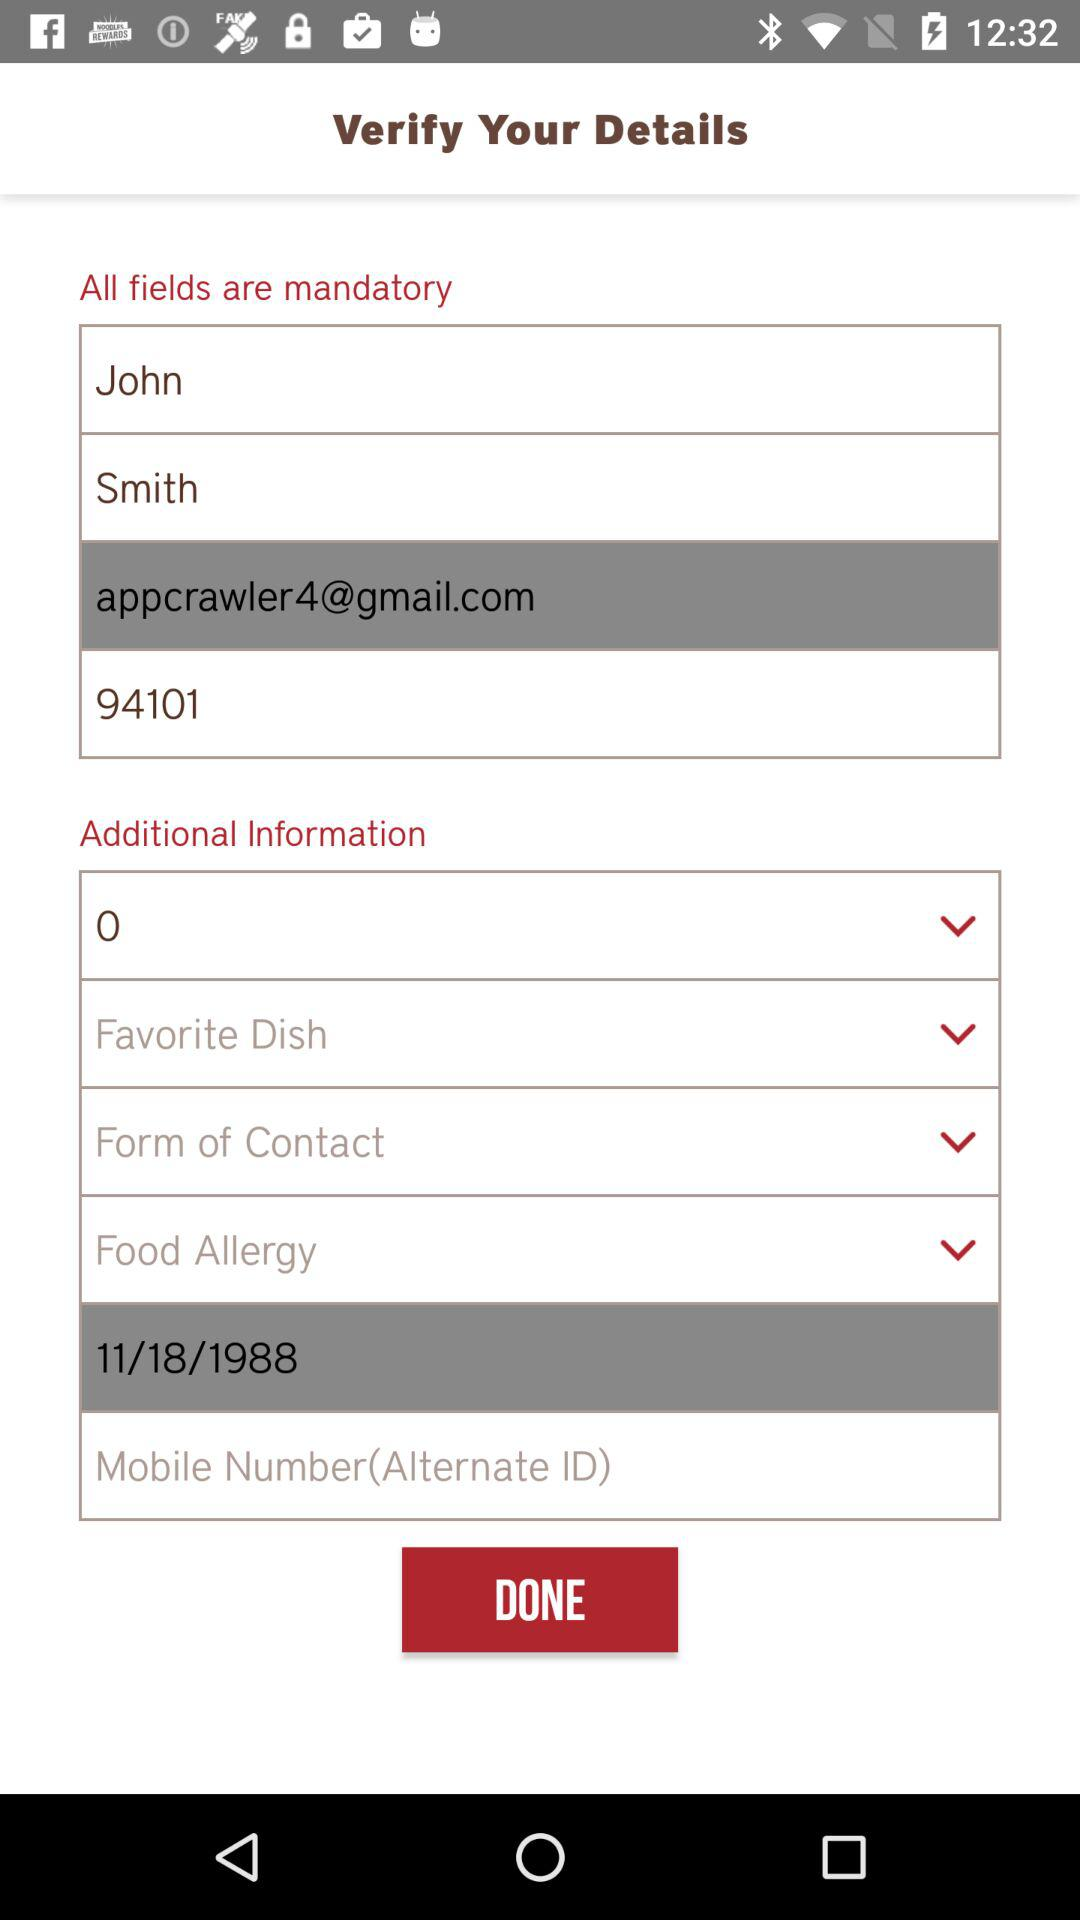How many text inputs have an email address format?
Answer the question using a single word or phrase. 1 